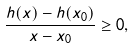<formula> <loc_0><loc_0><loc_500><loc_500>\frac { h ( x ) - h ( x _ { 0 } ) } { x - x _ { 0 } } \geq 0 ,</formula> 